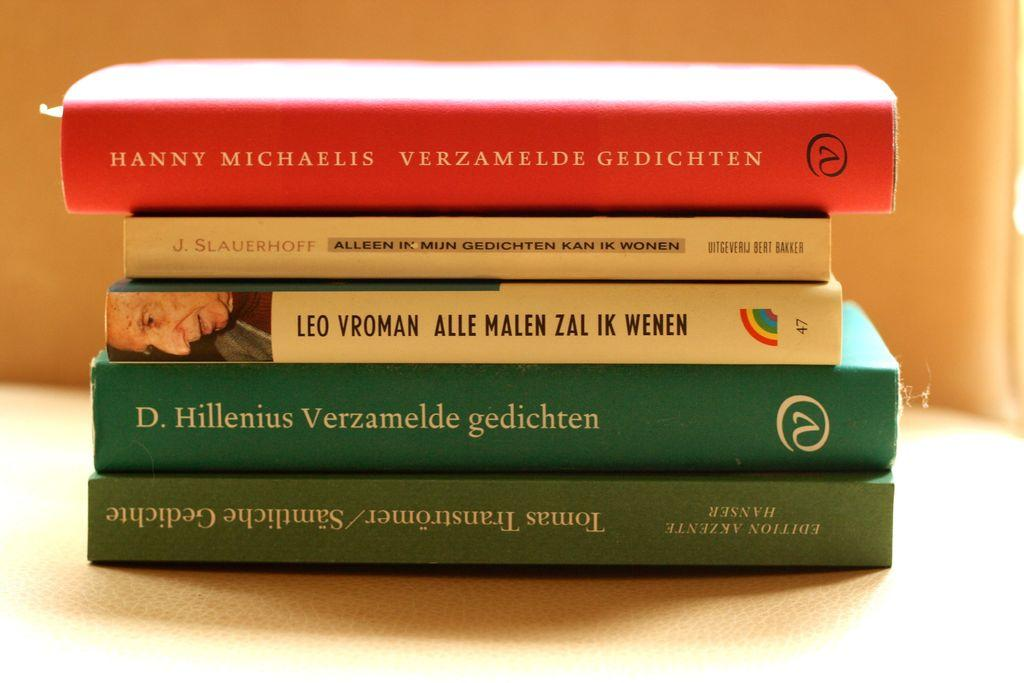What objects are visible on the surface in the image? There are books on a surface in the image. What color is the background of the image? The background of the image is cream-colored. What type of animal can be seen in the advertisement in the image? There is no animal or advertisement present in the image; it only features books on a surface and a cream-colored background. 